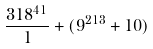<formula> <loc_0><loc_0><loc_500><loc_500>\frac { 3 1 8 ^ { 4 1 } } { 1 } + ( 9 ^ { 2 1 3 } + 1 0 )</formula> 